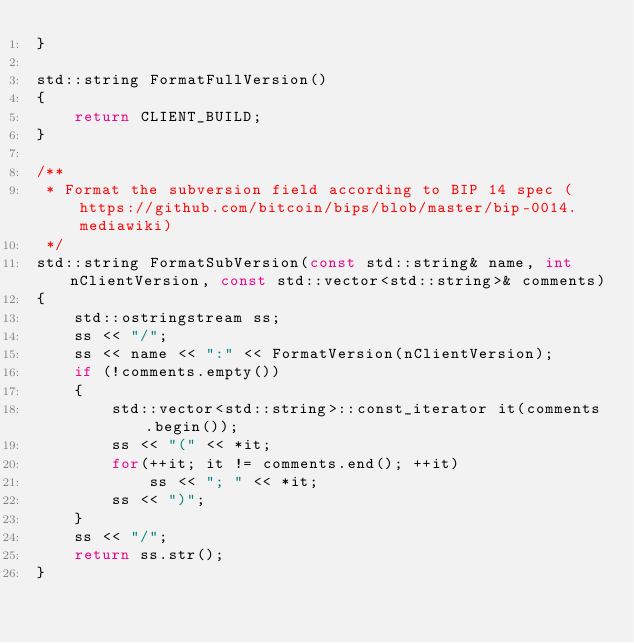Convert code to text. <code><loc_0><loc_0><loc_500><loc_500><_C++_>}

std::string FormatFullVersion()
{
    return CLIENT_BUILD;
}

/** 
 * Format the subversion field according to BIP 14 spec (https://github.com/bitcoin/bips/blob/master/bip-0014.mediawiki) 
 */
std::string FormatSubVersion(const std::string& name, int nClientVersion, const std::vector<std::string>& comments)
{
    std::ostringstream ss;
    ss << "/";
    ss << name << ":" << FormatVersion(nClientVersion);
    if (!comments.empty())
    {
        std::vector<std::string>::const_iterator it(comments.begin());
        ss << "(" << *it;
        for(++it; it != comments.end(); ++it)
            ss << "; " << *it;
        ss << ")";
    }
    ss << "/";
    return ss.str();
}
</code> 